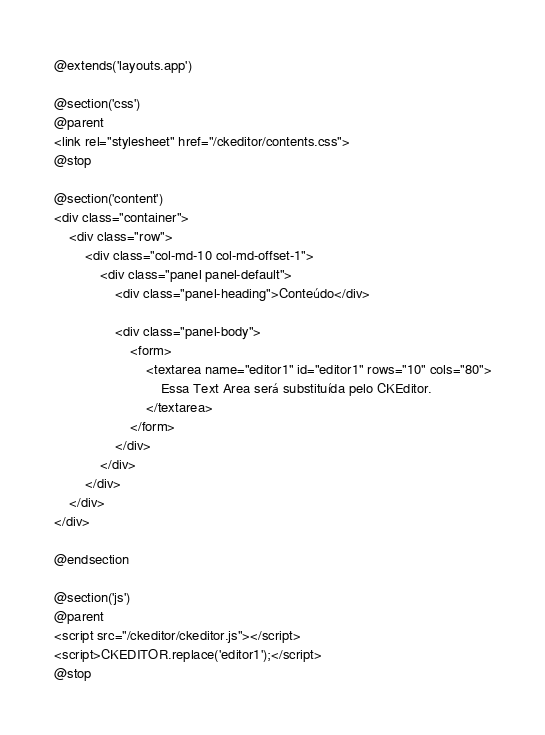Convert code to text. <code><loc_0><loc_0><loc_500><loc_500><_PHP_>@extends('layouts.app')

@section('css')
@parent
<link rel="stylesheet" href="/ckeditor/contents.css">
@stop

@section('content')
<div class="container">
    <div class="row">
        <div class="col-md-10 col-md-offset-1">
            <div class="panel panel-default">
                <div class="panel-heading">Conteúdo</div>

                <div class="panel-body">
                    <form>
			            <textarea name="editor1" id="editor1" rows="10" cols="80">
			                Essa Text Area será substituída pelo CKEditor.
			            </textarea>
			        </form>
                </div>
            </div>
        </div>
    </div>
</div>

@endsection

@section('js')
@parent
<script src="/ckeditor/ckeditor.js"></script>
<script>CKEDITOR.replace('editor1');</script>
@stop</code> 